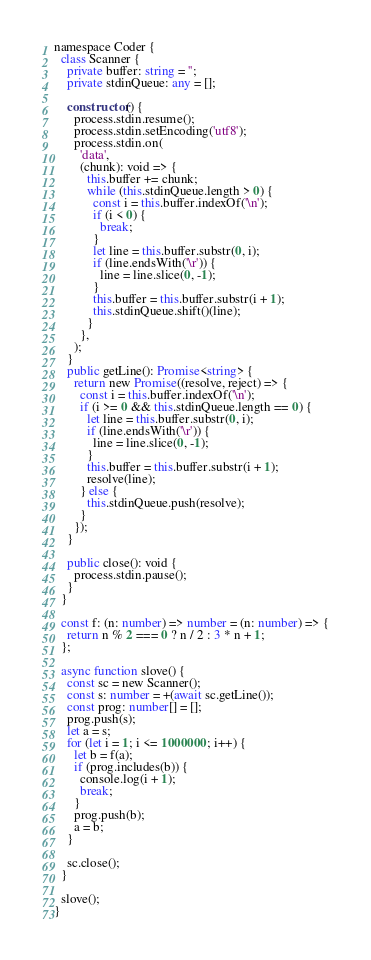<code> <loc_0><loc_0><loc_500><loc_500><_TypeScript_>namespace Coder {
  class Scanner {
    private buffer: string = '';
    private stdinQueue: any = [];

    constructor() {
      process.stdin.resume();
      process.stdin.setEncoding('utf8');
      process.stdin.on(
        'data',
        (chunk): void => {
          this.buffer += chunk;
          while (this.stdinQueue.length > 0) {
            const i = this.buffer.indexOf('\n');
            if (i < 0) {
              break;
            }
            let line = this.buffer.substr(0, i);
            if (line.endsWith('\r')) {
              line = line.slice(0, -1);
            }
            this.buffer = this.buffer.substr(i + 1);
            this.stdinQueue.shift()(line);
          }
        },
      );
    }
    public getLine(): Promise<string> {
      return new Promise((resolve, reject) => {
        const i = this.buffer.indexOf('\n');
        if (i >= 0 && this.stdinQueue.length == 0) {
          let line = this.buffer.substr(0, i);
          if (line.endsWith('\r')) {
            line = line.slice(0, -1);
          }
          this.buffer = this.buffer.substr(i + 1);
          resolve(line);
        } else {
          this.stdinQueue.push(resolve);
        }
      });
    }

    public close(): void {
      process.stdin.pause();
    }
  }

  const f: (n: number) => number = (n: number) => {
    return n % 2 === 0 ? n / 2 : 3 * n + 1;
  };

  async function slove() {
    const sc = new Scanner();
    const s: number = +(await sc.getLine());
    const prog: number[] = [];
    prog.push(s);
    let a = s;
    for (let i = 1; i <= 1000000; i++) {
      let b = f(a);
      if (prog.includes(b)) {
        console.log(i + 1);
        break;
      }
      prog.push(b);
      a = b;
    }

    sc.close();
  }

  slove();
}
</code> 